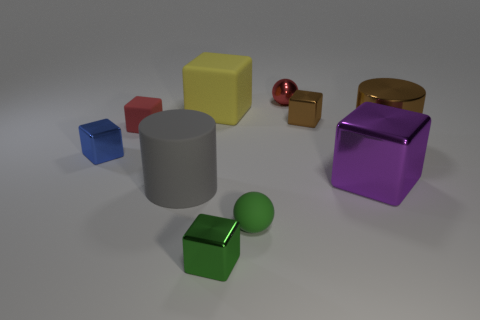Subtract all small green blocks. How many blocks are left? 5 Subtract all brown blocks. How many blocks are left? 5 Subtract 1 balls. How many balls are left? 1 Subtract all cylinders. How many objects are left? 8 Subtract 1 brown blocks. How many objects are left? 9 Subtract all yellow blocks. Subtract all gray cylinders. How many blocks are left? 5 Subtract all large yellow rubber cubes. Subtract all large blue metallic things. How many objects are left? 9 Add 4 large metallic objects. How many large metallic objects are left? 6 Add 7 large red shiny things. How many large red shiny things exist? 7 